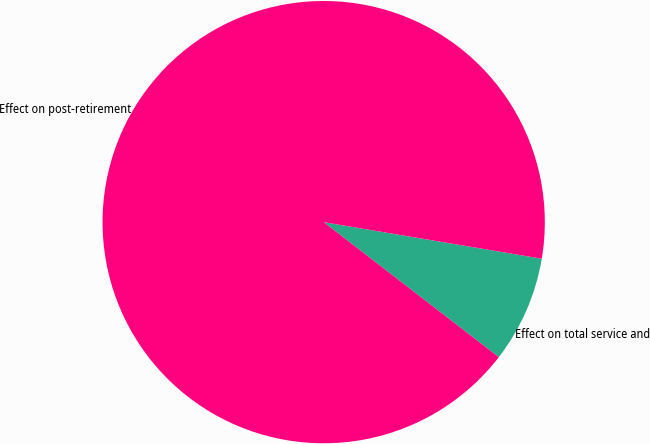<chart> <loc_0><loc_0><loc_500><loc_500><pie_chart><fcel>Effect on total service and<fcel>Effect on post-retirement<nl><fcel>7.81%<fcel>92.19%<nl></chart> 